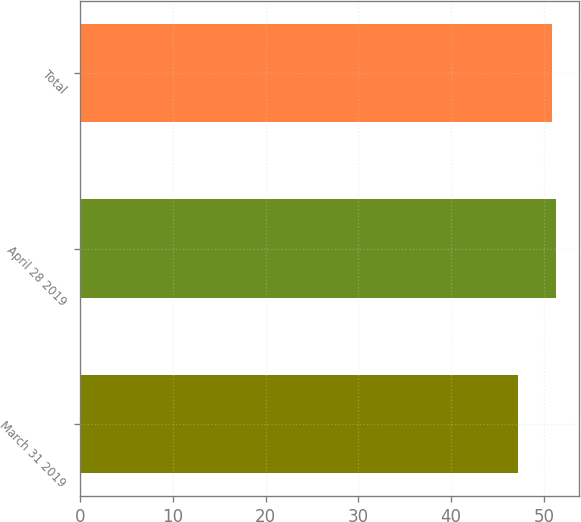Convert chart. <chart><loc_0><loc_0><loc_500><loc_500><bar_chart><fcel>March 31 2019<fcel>April 28 2019<fcel>Total<nl><fcel>47.22<fcel>51.26<fcel>50.88<nl></chart> 